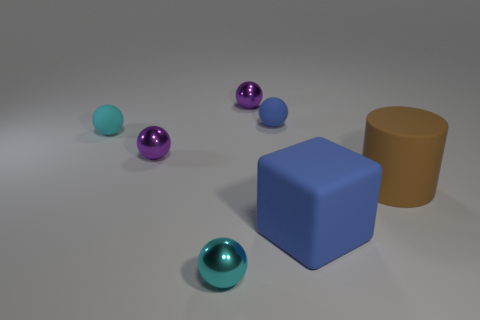What number of objects are both in front of the large cylinder and on the left side of the tiny blue rubber sphere? 1 